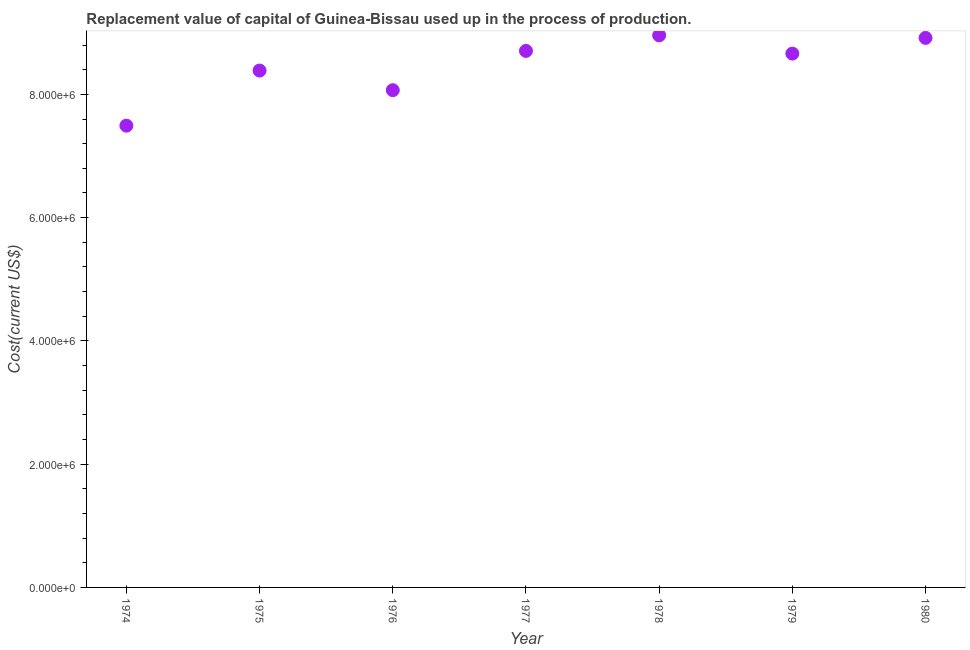What is the consumption of fixed capital in 1976?
Make the answer very short. 8.07e+06. Across all years, what is the maximum consumption of fixed capital?
Provide a succinct answer. 8.96e+06. Across all years, what is the minimum consumption of fixed capital?
Make the answer very short. 7.49e+06. In which year was the consumption of fixed capital maximum?
Offer a terse response. 1978. In which year was the consumption of fixed capital minimum?
Provide a short and direct response. 1974. What is the sum of the consumption of fixed capital?
Offer a terse response. 5.92e+07. What is the difference between the consumption of fixed capital in 1977 and 1978?
Ensure brevity in your answer.  -2.53e+05. What is the average consumption of fixed capital per year?
Give a very brief answer. 8.46e+06. What is the median consumption of fixed capital?
Your response must be concise. 8.66e+06. In how many years, is the consumption of fixed capital greater than 8400000 US$?
Keep it short and to the point. 4. What is the ratio of the consumption of fixed capital in 1974 to that in 1979?
Your answer should be compact. 0.86. Is the consumption of fixed capital in 1977 less than that in 1980?
Make the answer very short. Yes. What is the difference between the highest and the second highest consumption of fixed capital?
Provide a short and direct response. 4.15e+04. Is the sum of the consumption of fixed capital in 1974 and 1975 greater than the maximum consumption of fixed capital across all years?
Your response must be concise. Yes. What is the difference between the highest and the lowest consumption of fixed capital?
Provide a short and direct response. 1.47e+06. How many dotlines are there?
Your answer should be very brief. 1. How many years are there in the graph?
Make the answer very short. 7. What is the difference between two consecutive major ticks on the Y-axis?
Offer a terse response. 2.00e+06. Does the graph contain any zero values?
Offer a terse response. No. What is the title of the graph?
Ensure brevity in your answer.  Replacement value of capital of Guinea-Bissau used up in the process of production. What is the label or title of the Y-axis?
Keep it short and to the point. Cost(current US$). What is the Cost(current US$) in 1974?
Your response must be concise. 7.49e+06. What is the Cost(current US$) in 1975?
Offer a very short reply. 8.39e+06. What is the Cost(current US$) in 1976?
Your answer should be compact. 8.07e+06. What is the Cost(current US$) in 1977?
Your answer should be very brief. 8.71e+06. What is the Cost(current US$) in 1978?
Keep it short and to the point. 8.96e+06. What is the Cost(current US$) in 1979?
Your response must be concise. 8.66e+06. What is the Cost(current US$) in 1980?
Ensure brevity in your answer.  8.92e+06. What is the difference between the Cost(current US$) in 1974 and 1975?
Make the answer very short. -8.94e+05. What is the difference between the Cost(current US$) in 1974 and 1976?
Offer a very short reply. -5.76e+05. What is the difference between the Cost(current US$) in 1974 and 1977?
Make the answer very short. -1.21e+06. What is the difference between the Cost(current US$) in 1974 and 1978?
Your answer should be very brief. -1.47e+06. What is the difference between the Cost(current US$) in 1974 and 1979?
Offer a terse response. -1.17e+06. What is the difference between the Cost(current US$) in 1974 and 1980?
Your response must be concise. -1.42e+06. What is the difference between the Cost(current US$) in 1975 and 1976?
Your answer should be compact. 3.18e+05. What is the difference between the Cost(current US$) in 1975 and 1977?
Give a very brief answer. -3.19e+05. What is the difference between the Cost(current US$) in 1975 and 1978?
Give a very brief answer. -5.71e+05. What is the difference between the Cost(current US$) in 1975 and 1979?
Your answer should be compact. -2.75e+05. What is the difference between the Cost(current US$) in 1975 and 1980?
Keep it short and to the point. -5.30e+05. What is the difference between the Cost(current US$) in 1976 and 1977?
Your response must be concise. -6.37e+05. What is the difference between the Cost(current US$) in 1976 and 1978?
Your response must be concise. -8.90e+05. What is the difference between the Cost(current US$) in 1976 and 1979?
Provide a short and direct response. -5.93e+05. What is the difference between the Cost(current US$) in 1976 and 1980?
Your answer should be very brief. -8.48e+05. What is the difference between the Cost(current US$) in 1977 and 1978?
Your answer should be very brief. -2.53e+05. What is the difference between the Cost(current US$) in 1977 and 1979?
Offer a very short reply. 4.38e+04. What is the difference between the Cost(current US$) in 1977 and 1980?
Your answer should be compact. -2.11e+05. What is the difference between the Cost(current US$) in 1978 and 1979?
Offer a very short reply. 2.96e+05. What is the difference between the Cost(current US$) in 1978 and 1980?
Offer a terse response. 4.15e+04. What is the difference between the Cost(current US$) in 1979 and 1980?
Your answer should be compact. -2.55e+05. What is the ratio of the Cost(current US$) in 1974 to that in 1975?
Provide a short and direct response. 0.89. What is the ratio of the Cost(current US$) in 1974 to that in 1976?
Make the answer very short. 0.93. What is the ratio of the Cost(current US$) in 1974 to that in 1977?
Offer a terse response. 0.86. What is the ratio of the Cost(current US$) in 1974 to that in 1978?
Your answer should be very brief. 0.84. What is the ratio of the Cost(current US$) in 1974 to that in 1979?
Your answer should be compact. 0.86. What is the ratio of the Cost(current US$) in 1974 to that in 1980?
Keep it short and to the point. 0.84. What is the ratio of the Cost(current US$) in 1975 to that in 1976?
Your answer should be compact. 1.04. What is the ratio of the Cost(current US$) in 1975 to that in 1977?
Your answer should be compact. 0.96. What is the ratio of the Cost(current US$) in 1975 to that in 1978?
Offer a terse response. 0.94. What is the ratio of the Cost(current US$) in 1975 to that in 1980?
Offer a very short reply. 0.94. What is the ratio of the Cost(current US$) in 1976 to that in 1977?
Keep it short and to the point. 0.93. What is the ratio of the Cost(current US$) in 1976 to that in 1978?
Make the answer very short. 0.9. What is the ratio of the Cost(current US$) in 1976 to that in 1980?
Your response must be concise. 0.91. What is the ratio of the Cost(current US$) in 1977 to that in 1979?
Your response must be concise. 1. What is the ratio of the Cost(current US$) in 1978 to that in 1979?
Give a very brief answer. 1.03. 